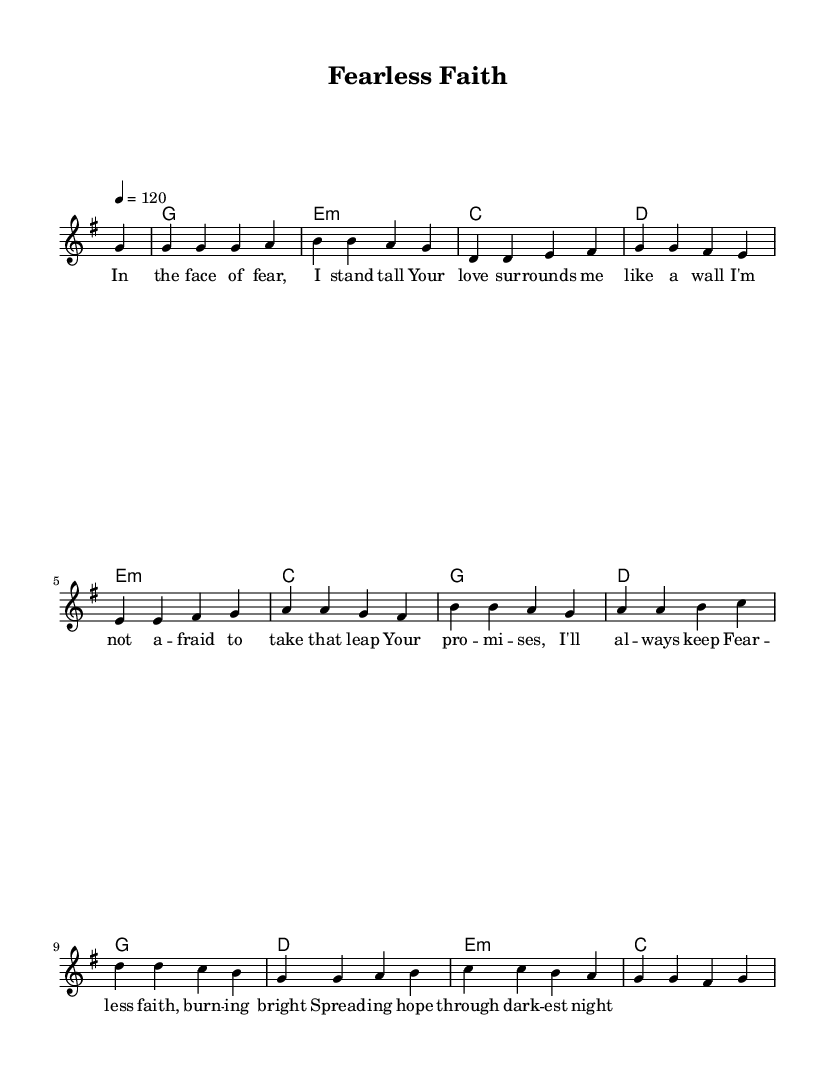What is the key signature of this music? The key signature is G major, which has one sharp (F#) indicated by the key signature at the beginning of the staff.
Answer: G major What is the time signature of the piece? The time signature shown at the beginning of the score is 4/4, which means there are four beats in each measure and the quarter note gets one beat.
Answer: 4/4 What is the tempo marking for this piece? The tempo marking specified in the score indicates a speed of quarter note equals 120 beats per minute, which is a moderately fast tempo.
Answer: 120 How many measures are in the melody? Counting the number of measures in the melody part, there are a total of 12 measures indicated by the notation between bar lines.
Answer: 12 What is the chord progression used in the first section? Analyzing the harmony section: the first chords are G major, E minor, C major, and D major, showing a common progression often used in uplifting anthems.
Answer: G, E minor, C, D What theme do the lyrics convey? The lyrics express themes of overcoming fear and trusting in divine love, which resonate well with contemporary Christian rock anthems aimed at providing hope and encouragement.
Answer: Hope and trust How does the title relate to the lyrics? The title "Fearless Faith" reflects the central message of the lyrics, emphasizing bravery in the face of fear through reliance on faith and divine support.
Answer: Faith over fear 